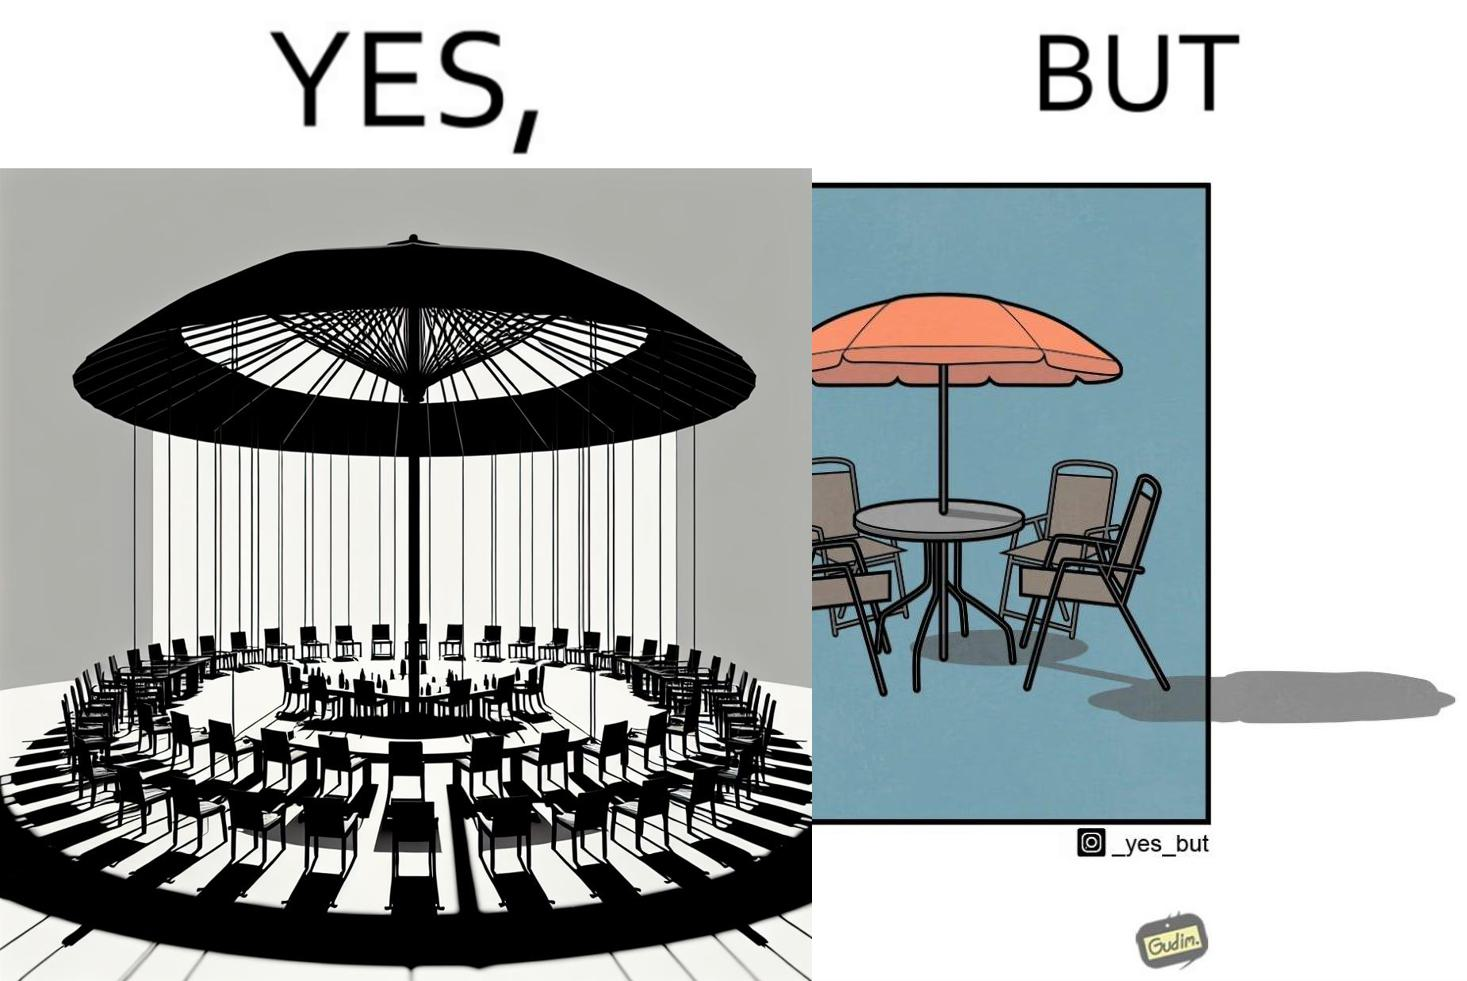Explain the humor or irony in this image. The image is ironical, as the umbrella is meant to provide shadow in the area where the chairs are present, but due to the orientation of the rays of the sun, all the chairs are in sunlight, and the umbrella is of no use in this situation. 